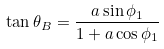Convert formula to latex. <formula><loc_0><loc_0><loc_500><loc_500>\tan \theta _ { B } = \frac { a \sin \phi _ { 1 } } { 1 + a \cos \phi _ { 1 } }</formula> 